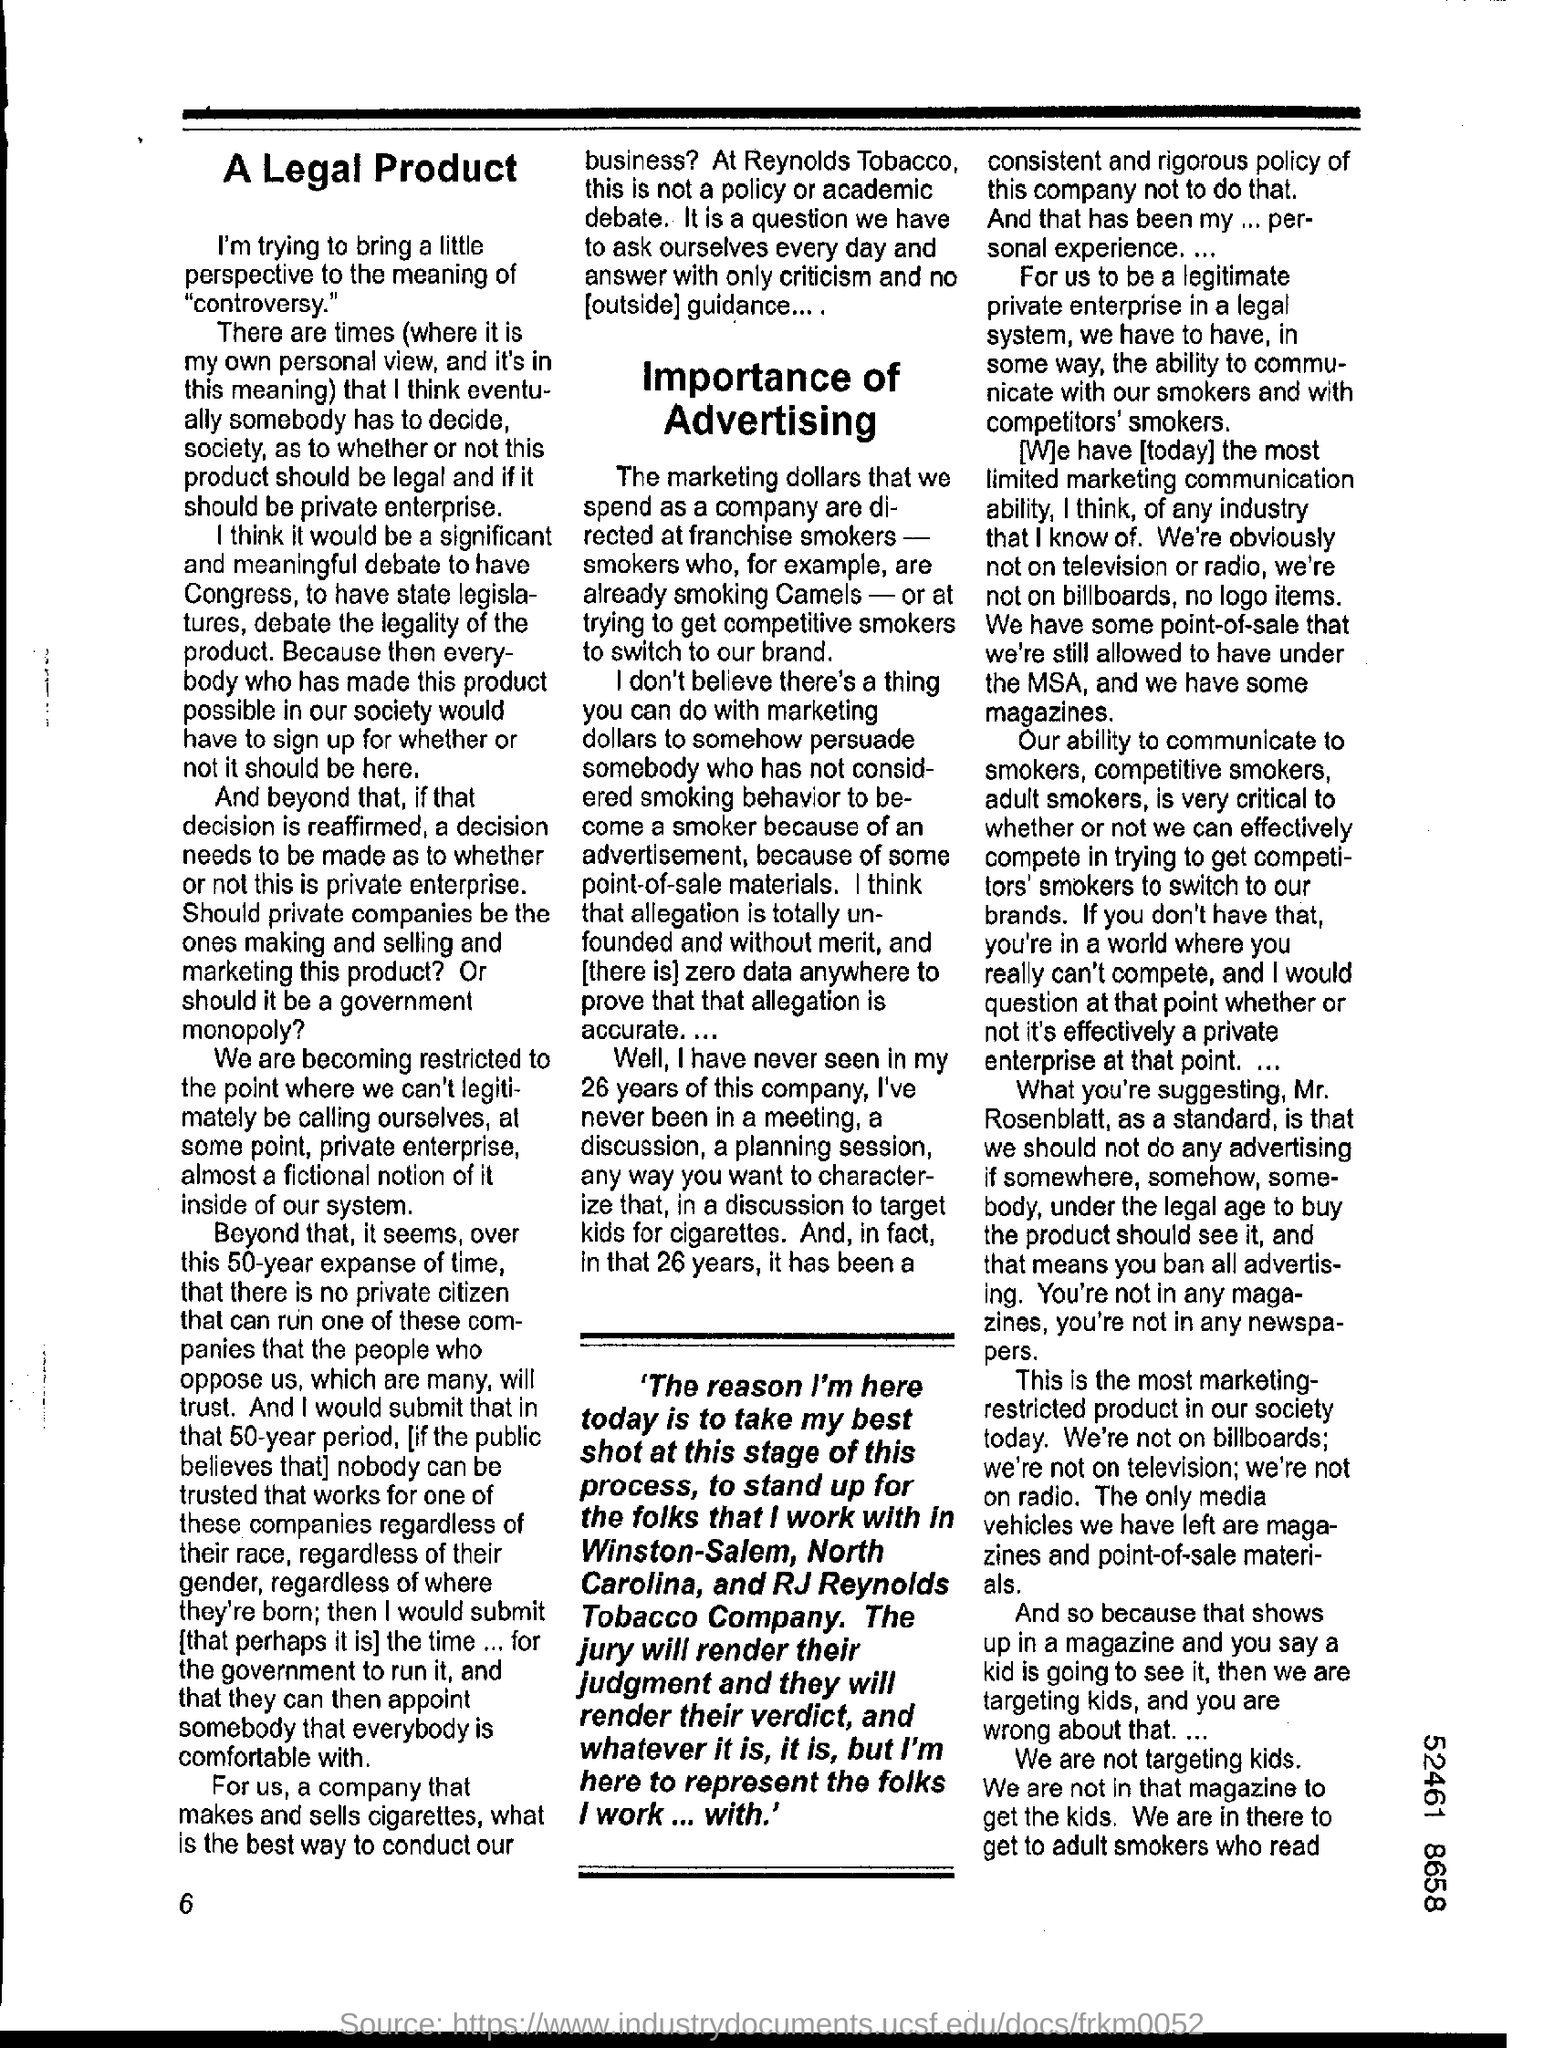What is the number at bottom left corner of the page ?
Keep it short and to the point. 6. 